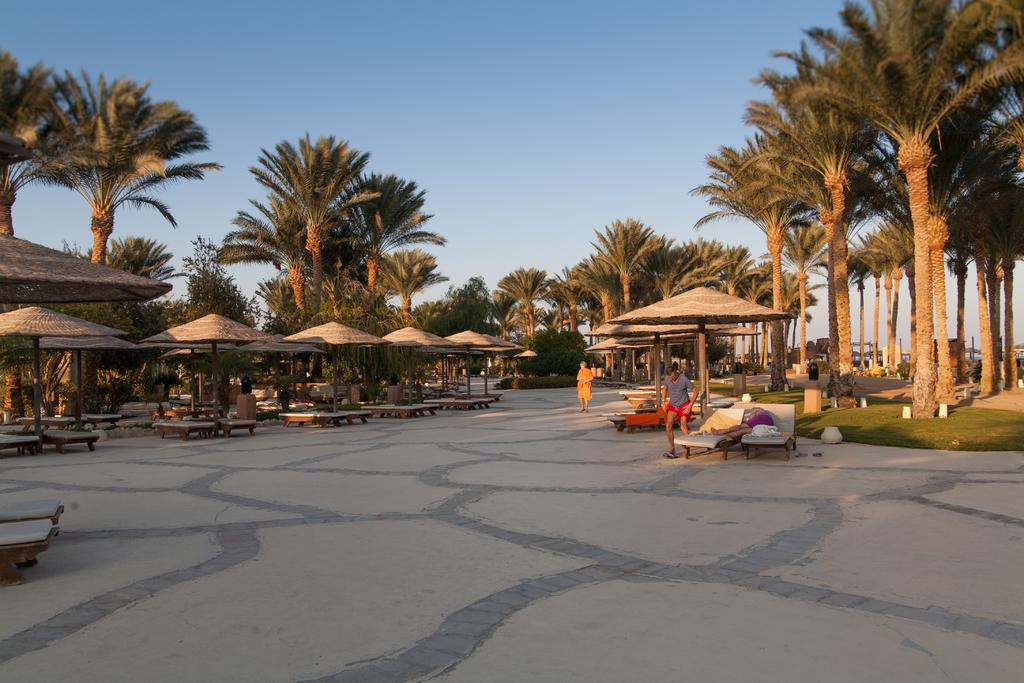What type of temporary shelters can be seen in the image? There are tents in the image. What type of seating is available in the image? There are benches in the image. Are there any people present in the image? Yes, there are people in the image. What type of vegetation is visible in the image? There are trees in the image. What is the ground covered with in the image? The ground has grass. What is visible in the background of the image? The sky is visible in the background of the image. What is the cause of the heat in the image? There is no mention of heat in the image, so it cannot be determined what the cause might be. Can you see a yoke in the image? There is no yoke present in the image. 